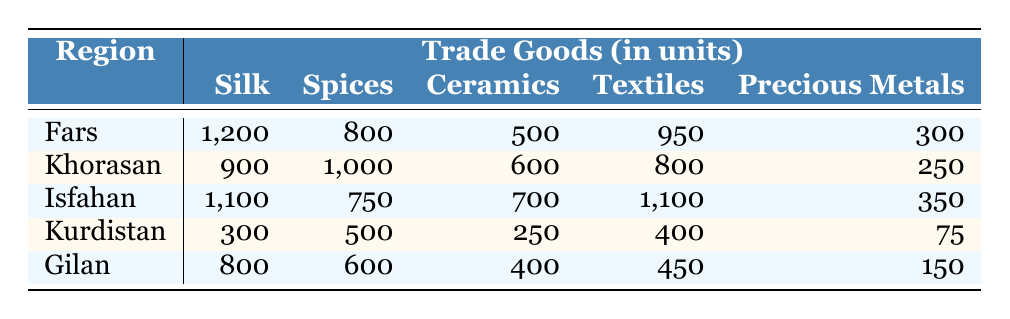What region has the highest amount of precious metals traded? By looking at the "Precious Metals" column, we can see that Fars has 300 units, Khorasan has 250, Isfahan has 350, Kurdistan has 75, and Gilan has 150. The highest value among these is 350 from Isfahan.
Answer: Isfahan Which region traded the most textiles? Checking the "Textiles" column, Fars has 950, Khorasan has 800, Isfahan has 1100, Kurdistan has 400, and Gilan has 450. The highest value is 1100 from Isfahan.
Answer: Isfahan What is the total amount of spices traded across all regions? Summing the values from the "Spices" column: 800 (Fars) + 1000 (Khorasan) + 750 (Isfahan) + 500 (Kurdistan) + 600 (Gilan) = 3650.
Answer: 3650 Is the amount of silk traded in Khorasan greater than in Kurdistan? Khorasan has 900 units of silk, while Kurdistan has 300 units. Since 900 is greater than 300, the statement is true.
Answer: Yes What is the average amount of ceramics traded across all regions? The values in the "Ceramics" column are 500 (Fars), 600 (Khorasan), 700 (Isfahan), 250 (Kurdistan), and 400 (Gilan). Adding these gives a total of 2450, and there are 5 regions, so the average is 2450 / 5 = 490.
Answer: 490 Which region has the least amount of traded goods overall? First, we calculate the total goods for each region: Fars has 3850, Khorasan has 3450, Isfahan has 3900, Kurdistan has 1525, and Gilan has 3050. The least total is 1525 in Kurdistan.
Answer: Kurdistan What is the difference in the amount of silk traded between Khorasan and Gilan? Khorasan has 900 units of silk and Gilan has 800. The difference is calculated as 900 - 800, which is 100.
Answer: 100 Does Isfahan trade more ceramics than Gilan? Isfahan trades 700 ceramics while Gilan trades 400. Since 700 is greater than 400, the answer is yes.
Answer: Yes What is the total value of all precious metals traded in Fars and Isfahan combined? Fars has 300 units and Isfahan has 350 units of precious metals. Therefore, the total is 300 + 350 = 650.
Answer: 650 